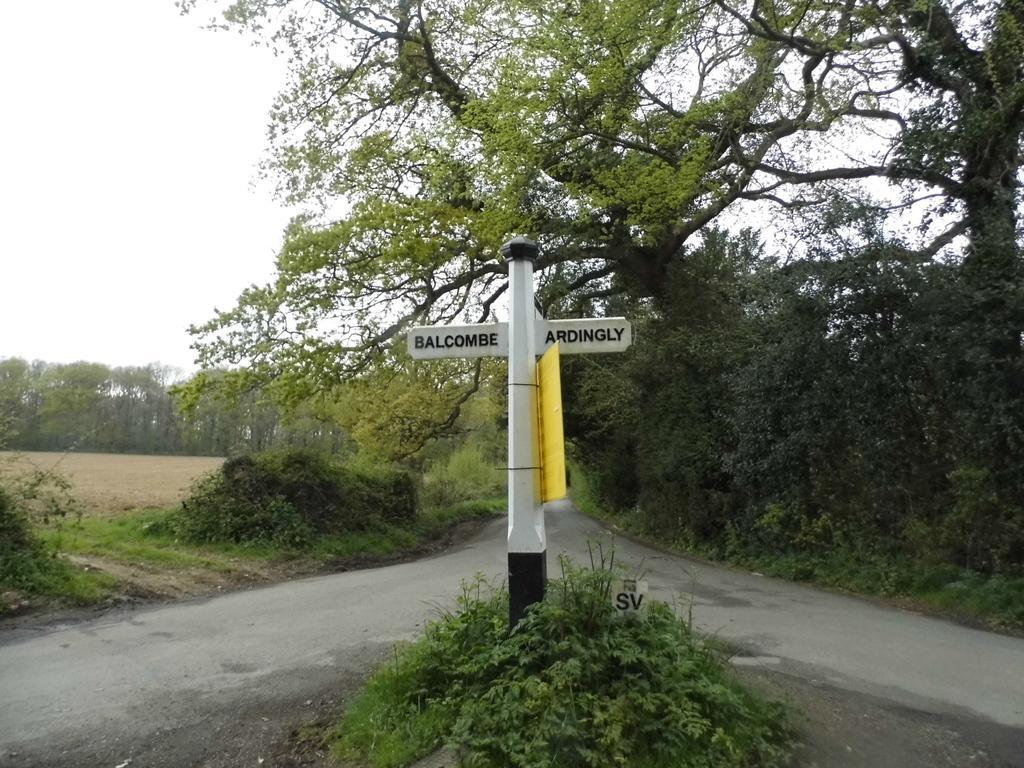Could you give a brief overview of what you see in this image? In this image I can see a white colored pole and a yellow colored board to the pole. I can see a plant, the road and few trees. In the background I can see few trees and the sky. 